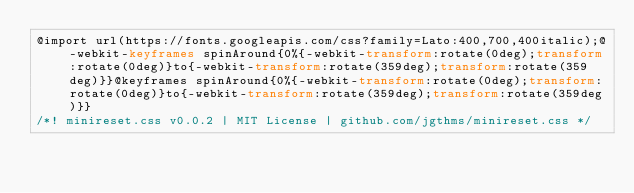Convert code to text. <code><loc_0><loc_0><loc_500><loc_500><_CSS_>@import url(https://fonts.googleapis.com/css?family=Lato:400,700,400italic);@-webkit-keyframes spinAround{0%{-webkit-transform:rotate(0deg);transform:rotate(0deg)}to{-webkit-transform:rotate(359deg);transform:rotate(359deg)}}@keyframes spinAround{0%{-webkit-transform:rotate(0deg);transform:rotate(0deg)}to{-webkit-transform:rotate(359deg);transform:rotate(359deg)}}
/*! minireset.css v0.0.2 | MIT License | github.com/jgthms/minireset.css */</code> 